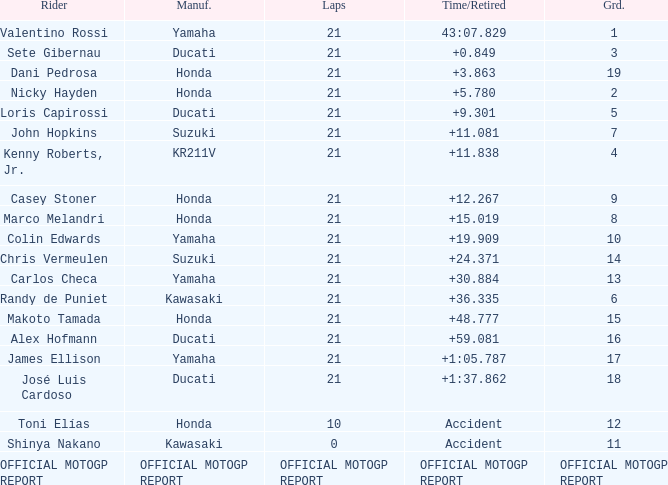What is the time/retired for the rider with the manufacturuer yamaha, grod of 1 and 21 total laps? 43:07.829. 